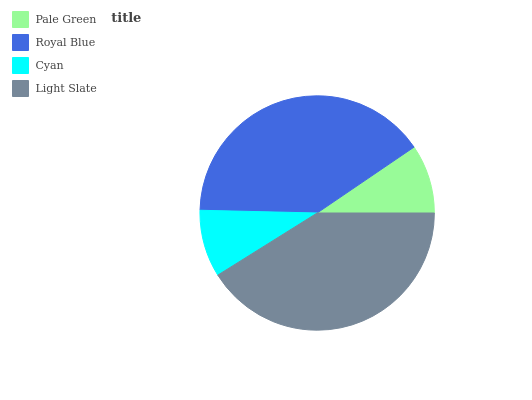Is Cyan the minimum?
Answer yes or no. Yes. Is Light Slate the maximum?
Answer yes or no. Yes. Is Royal Blue the minimum?
Answer yes or no. No. Is Royal Blue the maximum?
Answer yes or no. No. Is Royal Blue greater than Pale Green?
Answer yes or no. Yes. Is Pale Green less than Royal Blue?
Answer yes or no. Yes. Is Pale Green greater than Royal Blue?
Answer yes or no. No. Is Royal Blue less than Pale Green?
Answer yes or no. No. Is Royal Blue the high median?
Answer yes or no. Yes. Is Pale Green the low median?
Answer yes or no. Yes. Is Light Slate the high median?
Answer yes or no. No. Is Royal Blue the low median?
Answer yes or no. No. 